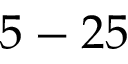Convert formula to latex. <formula><loc_0><loc_0><loc_500><loc_500>5 - 2 5</formula> 